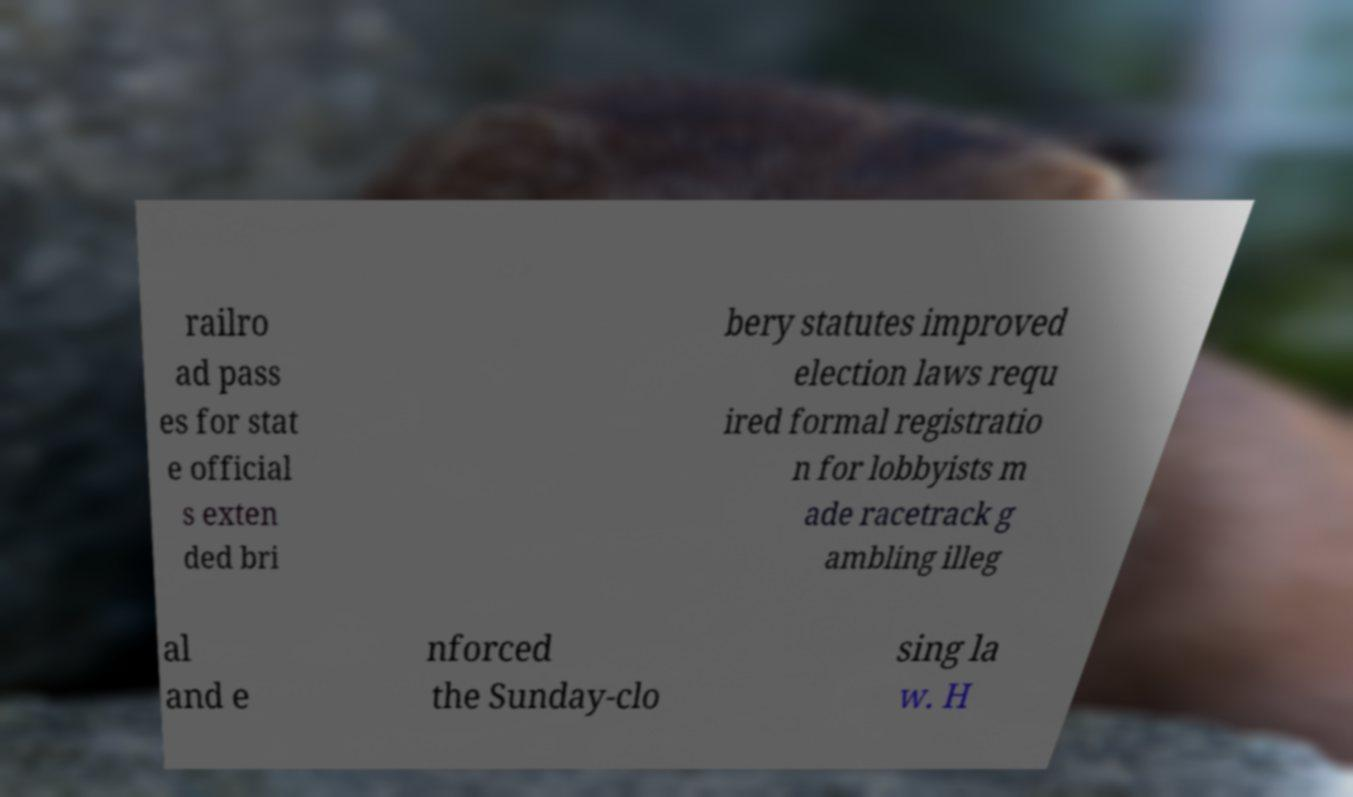What messages or text are displayed in this image? I need them in a readable, typed format. railro ad pass es for stat e official s exten ded bri bery statutes improved election laws requ ired formal registratio n for lobbyists m ade racetrack g ambling illeg al and e nforced the Sunday-clo sing la w. H 